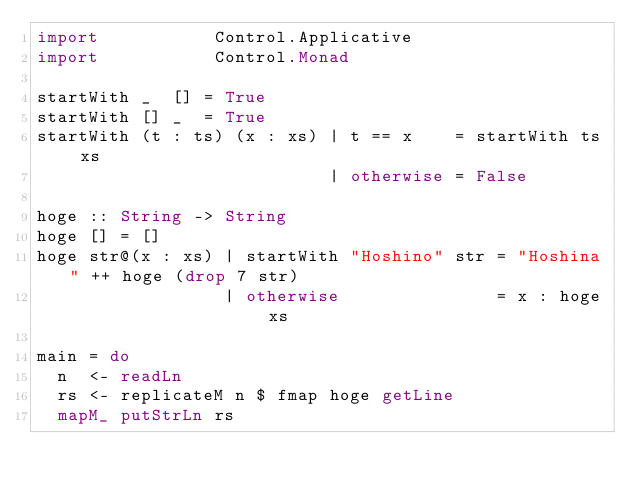<code> <loc_0><loc_0><loc_500><loc_500><_Haskell_>import           Control.Applicative
import           Control.Monad

startWith _  [] = True
startWith [] _  = True
startWith (t : ts) (x : xs) | t == x    = startWith ts xs
                            | otherwise = False

hoge :: String -> String
hoge [] = []
hoge str@(x : xs) | startWith "Hoshino" str = "Hoshina" ++ hoge (drop 7 str)
                  | otherwise               = x : hoge xs

main = do
  n  <- readLn
  rs <- replicateM n $ fmap hoge getLine
  mapM_ putStrLn rs

</code> 